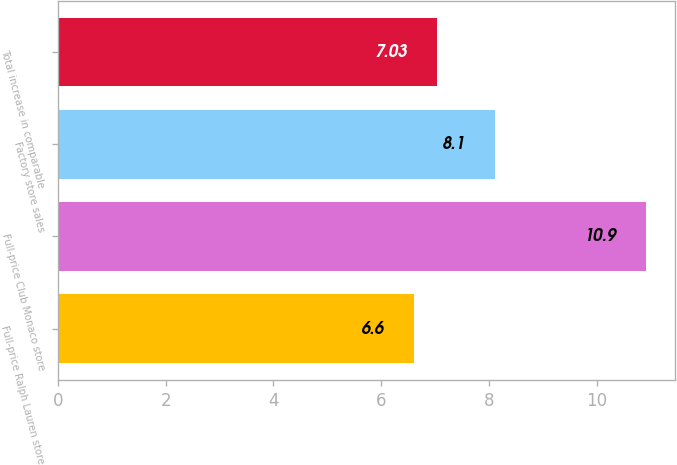Convert chart to OTSL. <chart><loc_0><loc_0><loc_500><loc_500><bar_chart><fcel>Full-price Ralph Lauren store<fcel>Full-price Club Monaco store<fcel>Factory store sales<fcel>Total increase in comparable<nl><fcel>6.6<fcel>10.9<fcel>8.1<fcel>7.03<nl></chart> 